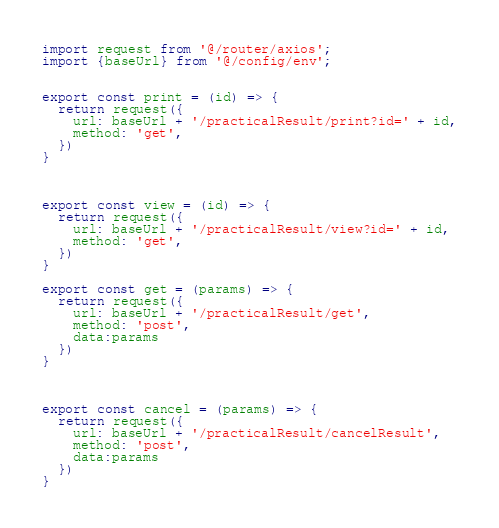Convert code to text. <code><loc_0><loc_0><loc_500><loc_500><_JavaScript_>import request from '@/router/axios';
import {baseUrl} from '@/config/env';


export const print = (id) => {
  return request({
    url: baseUrl + '/practicalResult/print?id=' + id,
    method: 'get',
  })
}



export const view = (id) => {
  return request({
    url: baseUrl + '/practicalResult/view?id=' + id,
    method: 'get',
  })
}

export const get = (params) => {
  return request({
    url: baseUrl + '/practicalResult/get',
    method: 'post',
    data:params
  })
}



export const cancel = (params) => {
  return request({
    url: baseUrl + '/practicalResult/cancelResult',
    method: 'post',
    data:params
  })
}



</code> 